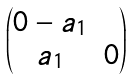<formula> <loc_0><loc_0><loc_500><loc_500>\begin{pmatrix} 0 - a _ { 1 } \\ a _ { 1 } & 0 \end{pmatrix}</formula> 